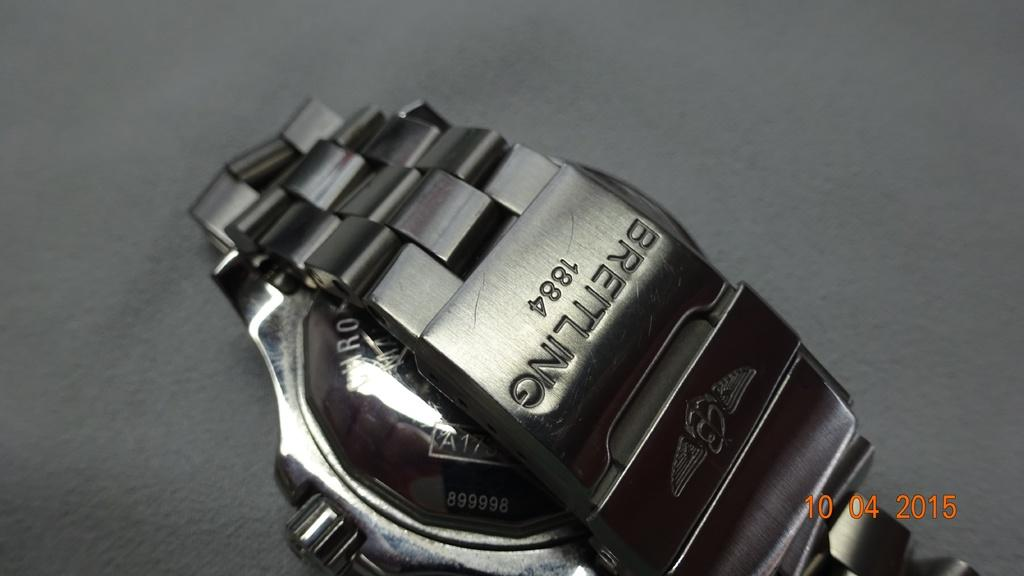<image>
Present a compact description of the photo's key features. A silver watch band with Breitling engraved on it 